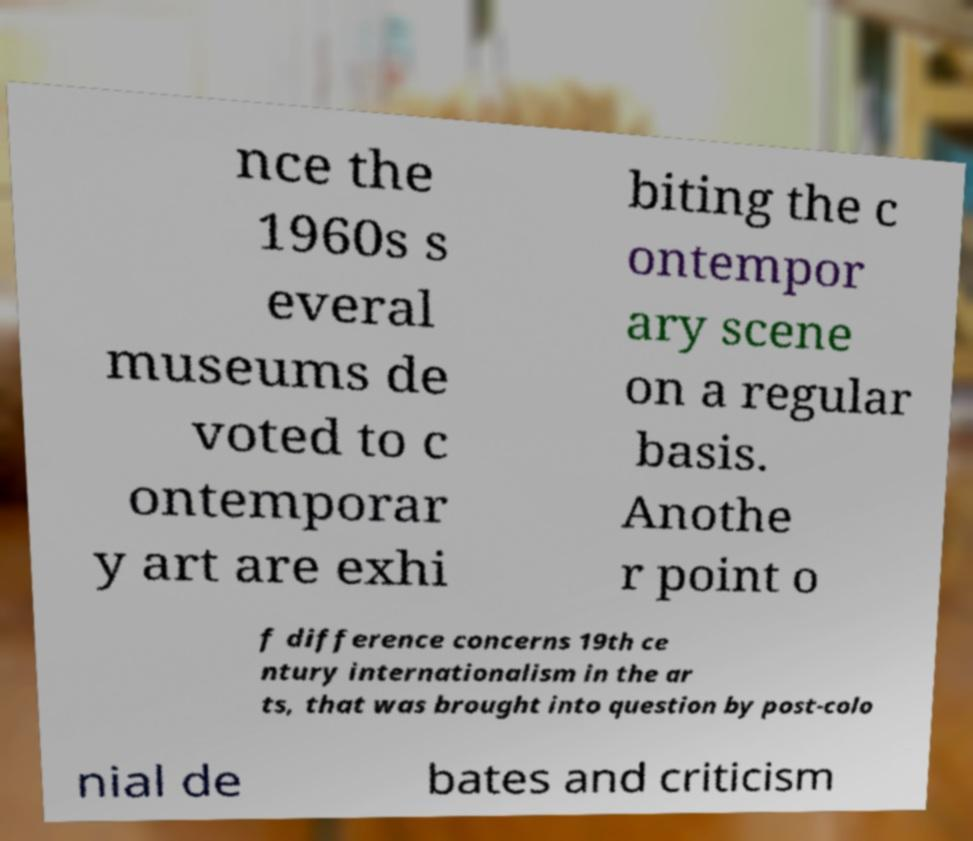Please read and relay the text visible in this image. What does it say? nce the 1960s s everal museums de voted to c ontemporar y art are exhi biting the c ontempor ary scene on a regular basis. Anothe r point o f difference concerns 19th ce ntury internationalism in the ar ts, that was brought into question by post-colo nial de bates and criticism 